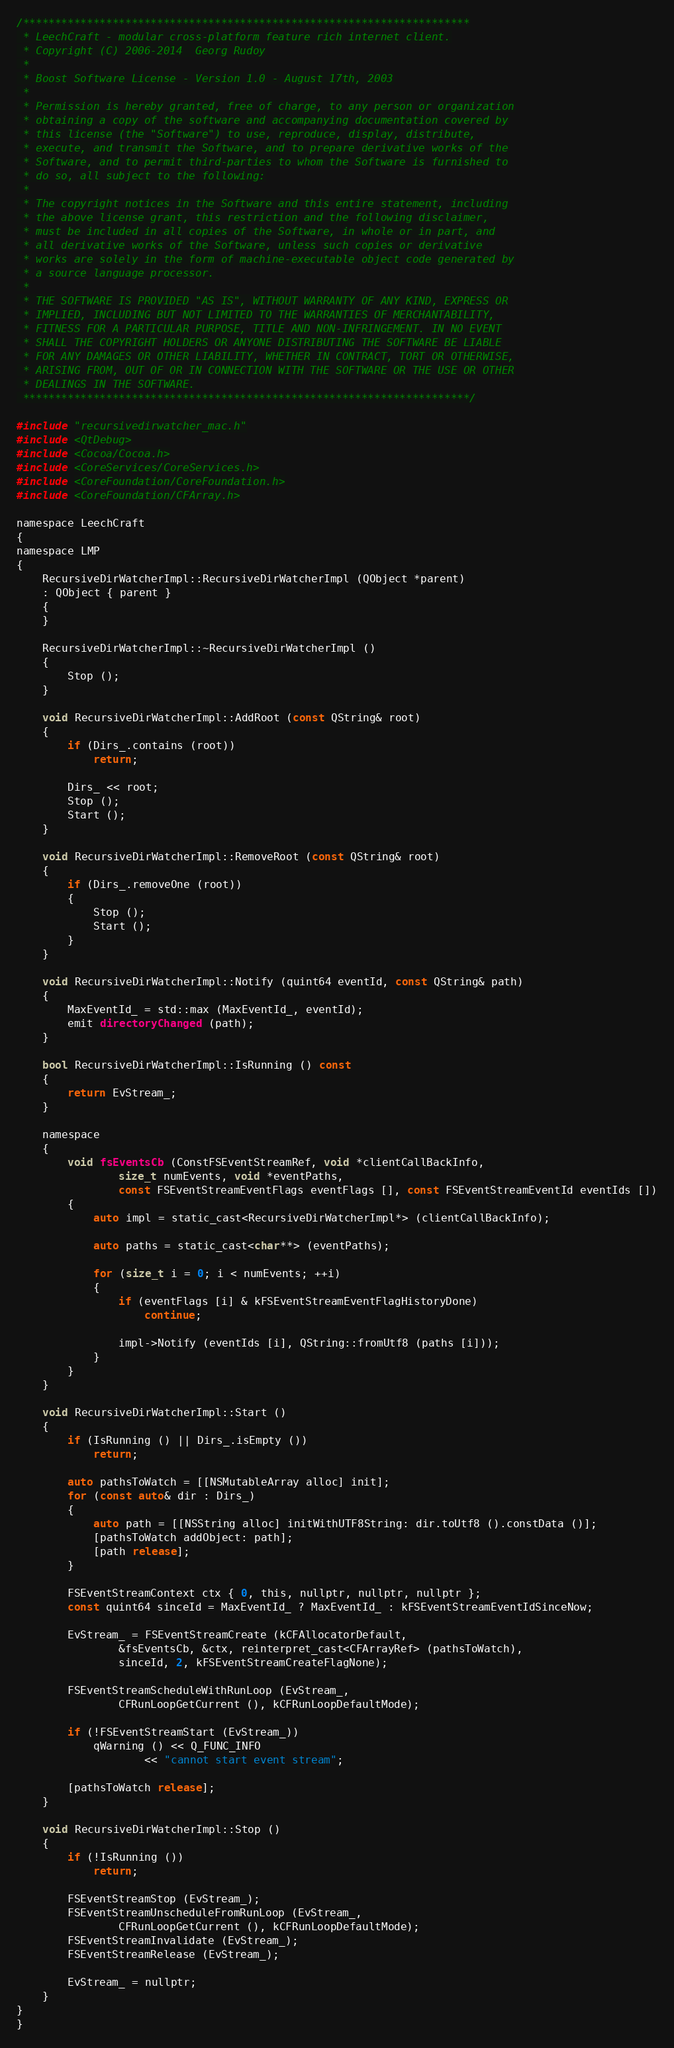Convert code to text. <code><loc_0><loc_0><loc_500><loc_500><_ObjectiveC_>/**********************************************************************
 * LeechCraft - modular cross-platform feature rich internet client.
 * Copyright (C) 2006-2014  Georg Rudoy
 *
 * Boost Software License - Version 1.0 - August 17th, 2003
 *
 * Permission is hereby granted, free of charge, to any person or organization
 * obtaining a copy of the software and accompanying documentation covered by
 * this license (the "Software") to use, reproduce, display, distribute,
 * execute, and transmit the Software, and to prepare derivative works of the
 * Software, and to permit third-parties to whom the Software is furnished to
 * do so, all subject to the following:
 *
 * The copyright notices in the Software and this entire statement, including
 * the above license grant, this restriction and the following disclaimer,
 * must be included in all copies of the Software, in whole or in part, and
 * all derivative works of the Software, unless such copies or derivative
 * works are solely in the form of machine-executable object code generated by
 * a source language processor.
 *
 * THE SOFTWARE IS PROVIDED "AS IS", WITHOUT WARRANTY OF ANY KIND, EXPRESS OR
 * IMPLIED, INCLUDING BUT NOT LIMITED TO THE WARRANTIES OF MERCHANTABILITY,
 * FITNESS FOR A PARTICULAR PURPOSE, TITLE AND NON-INFRINGEMENT. IN NO EVENT
 * SHALL THE COPYRIGHT HOLDERS OR ANYONE DISTRIBUTING THE SOFTWARE BE LIABLE
 * FOR ANY DAMAGES OR OTHER LIABILITY, WHETHER IN CONTRACT, TORT OR OTHERWISE,
 * ARISING FROM, OUT OF OR IN CONNECTION WITH THE SOFTWARE OR THE USE OR OTHER
 * DEALINGS IN THE SOFTWARE.
 **********************************************************************/

#include "recursivedirwatcher_mac.h"
#include <QtDebug>
#include <Cocoa/Cocoa.h>
#include <CoreServices/CoreServices.h>
#include <CoreFoundation/CoreFoundation.h>
#include <CoreFoundation/CFArray.h>

namespace LeechCraft
{
namespace LMP
{
	RecursiveDirWatcherImpl::RecursiveDirWatcherImpl (QObject *parent)
	: QObject { parent }
	{
	}

	RecursiveDirWatcherImpl::~RecursiveDirWatcherImpl ()
	{
		Stop ();
	}

	void RecursiveDirWatcherImpl::AddRoot (const QString& root)
	{
		if (Dirs_.contains (root))
			return;

		Dirs_ << root;
		Stop ();
		Start ();
	}

	void RecursiveDirWatcherImpl::RemoveRoot (const QString& root)
	{
		if (Dirs_.removeOne (root))
		{
			Stop ();
			Start ();
		}
	}

	void RecursiveDirWatcherImpl::Notify (quint64 eventId, const QString& path)
	{
		MaxEventId_ = std::max (MaxEventId_, eventId);
		emit directoryChanged (path);
	}

	bool RecursiveDirWatcherImpl::IsRunning () const
	{
		return EvStream_;
	}

	namespace
	{
		void fsEventsCb (ConstFSEventStreamRef, void *clientCallBackInfo,
				size_t numEvents, void *eventPaths,
				const FSEventStreamEventFlags eventFlags [], const FSEventStreamEventId eventIds [])
		{
			auto impl = static_cast<RecursiveDirWatcherImpl*> (clientCallBackInfo);

			auto paths = static_cast<char**> (eventPaths);

			for (size_t i = 0; i < numEvents; ++i)
			{
				if (eventFlags [i] & kFSEventStreamEventFlagHistoryDone)
					continue;

				impl->Notify (eventIds [i], QString::fromUtf8 (paths [i]));
			}
		}
	}

	void RecursiveDirWatcherImpl::Start ()
	{
		if (IsRunning () || Dirs_.isEmpty ())
			return;

		auto pathsToWatch = [[NSMutableArray alloc] init];
		for (const auto& dir : Dirs_)
		{
			auto path = [[NSString alloc] initWithUTF8String: dir.toUtf8 ().constData ()];
			[pathsToWatch addObject: path];
			[path release];
		}

		FSEventStreamContext ctx { 0, this, nullptr, nullptr, nullptr };
		const quint64 sinceId = MaxEventId_ ? MaxEventId_ : kFSEventStreamEventIdSinceNow;

		EvStream_ = FSEventStreamCreate (kCFAllocatorDefault,
				&fsEventsCb, &ctx, reinterpret_cast<CFArrayRef> (pathsToWatch),
				sinceId, 2, kFSEventStreamCreateFlagNone);

		FSEventStreamScheduleWithRunLoop (EvStream_,
				CFRunLoopGetCurrent (), kCFRunLoopDefaultMode);

		if (!FSEventStreamStart (EvStream_))
			qWarning () << Q_FUNC_INFO
					<< "cannot start event stream";

		[pathsToWatch release];
	}

	void RecursiveDirWatcherImpl::Stop ()
	{
		if (!IsRunning ())
			return;

		FSEventStreamStop (EvStream_);
		FSEventStreamUnscheduleFromRunLoop (EvStream_,
				CFRunLoopGetCurrent (), kCFRunLoopDefaultMode);
		FSEventStreamInvalidate (EvStream_);
		FSEventStreamRelease (EvStream_);

		EvStream_ = nullptr;
	}
}
}
</code> 